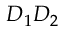<formula> <loc_0><loc_0><loc_500><loc_500>D _ { 1 } D _ { 2 }</formula> 